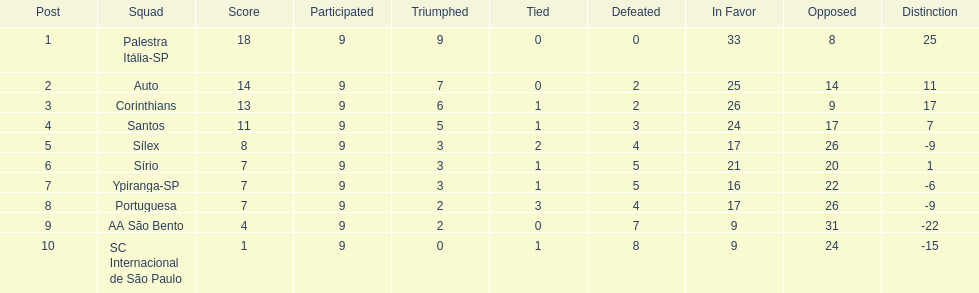In 1926 brazilian football,aside from the first place team, what other teams had winning records? Auto, Corinthians, Santos. 